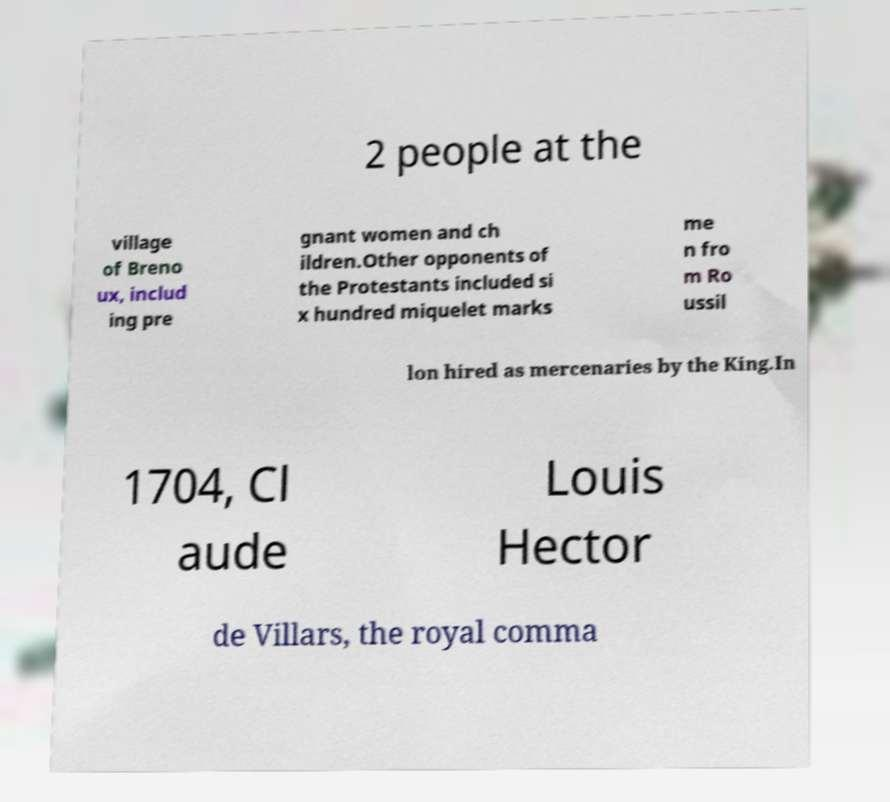For documentation purposes, I need the text within this image transcribed. Could you provide that? 2 people at the village of Breno ux, includ ing pre gnant women and ch ildren.Other opponents of the Protestants included si x hundred miquelet marks me n fro m Ro ussil lon hired as mercenaries by the King.In 1704, Cl aude Louis Hector de Villars, the royal comma 